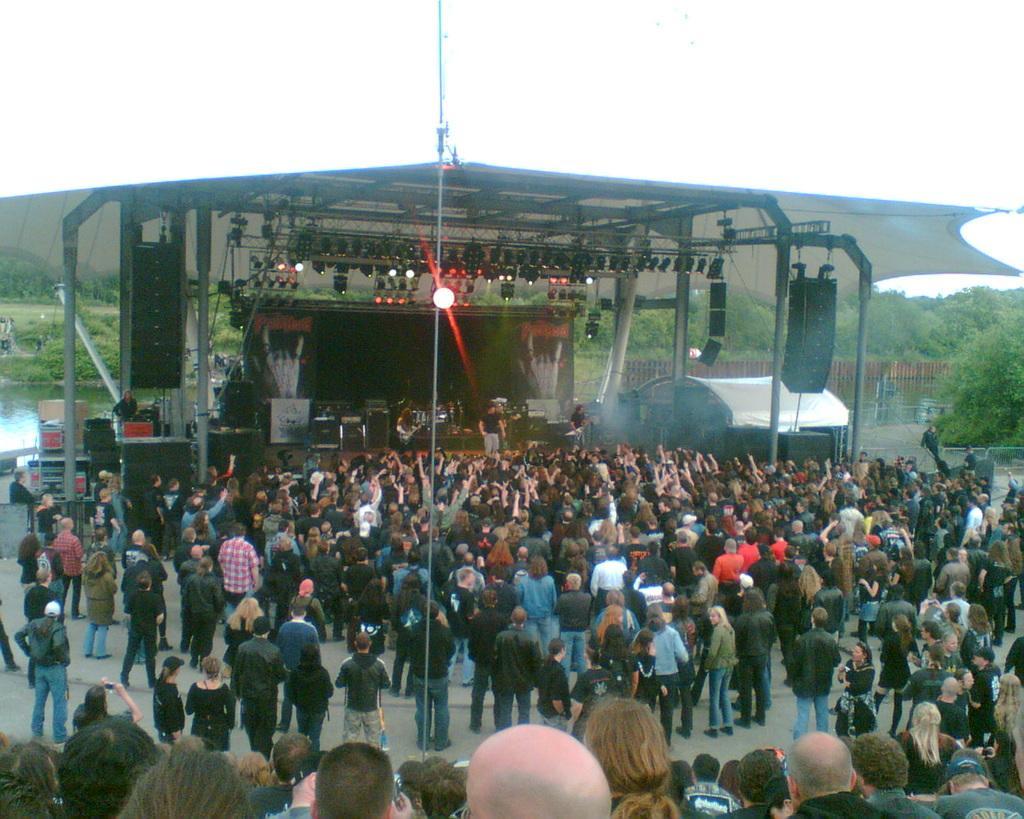Describe this image in one or two sentences. In the center of the image we can see people standing on the stage and there are lights. At the bottom there is crowd. In the background we can see a fence, trees, tent, water and sky. 